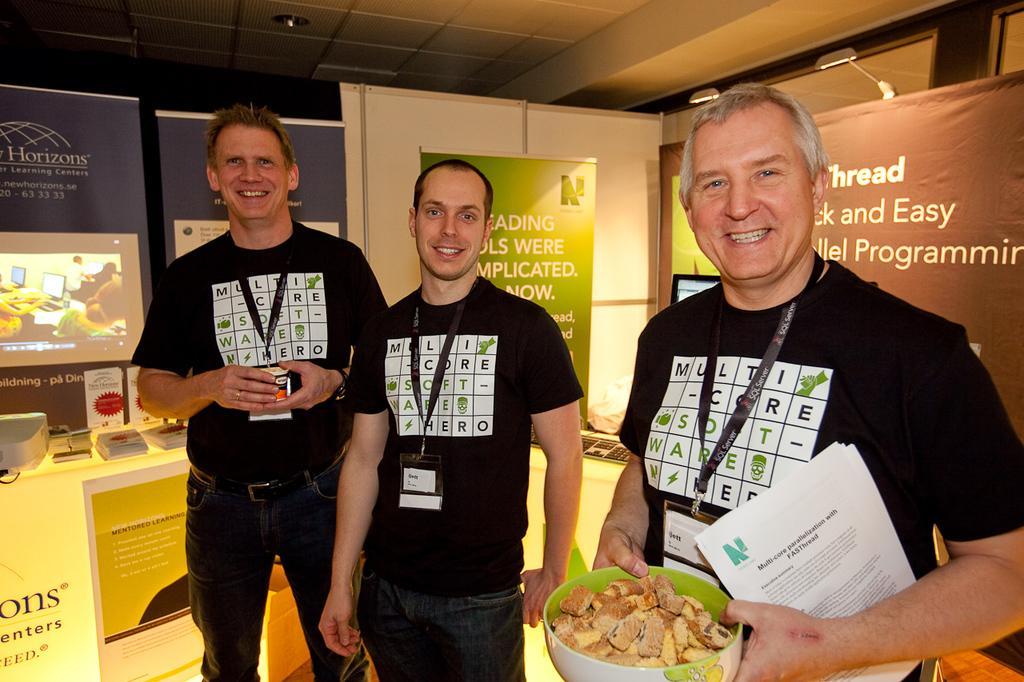Could you give a brief overview of what you see in this image? In this image I can see three persons standing. In front the person is holding the food and the food is in the bowl and I can also see few papers. In the background I can see few banners and few objects on the white color surface. 